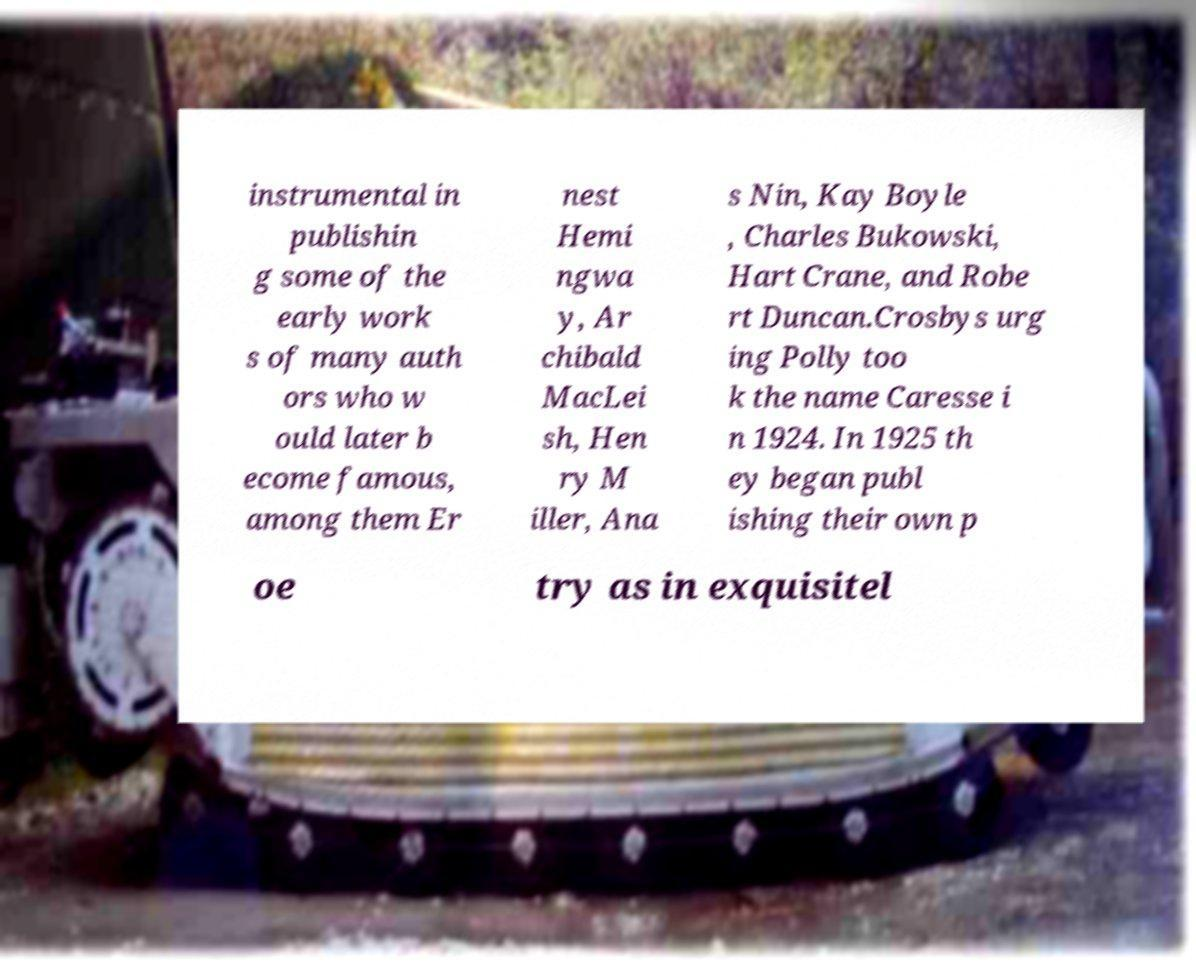Can you accurately transcribe the text from the provided image for me? instrumental in publishin g some of the early work s of many auth ors who w ould later b ecome famous, among them Er nest Hemi ngwa y, Ar chibald MacLei sh, Hen ry M iller, Ana s Nin, Kay Boyle , Charles Bukowski, Hart Crane, and Robe rt Duncan.Crosbys urg ing Polly too k the name Caresse i n 1924. In 1925 th ey began publ ishing their own p oe try as in exquisitel 